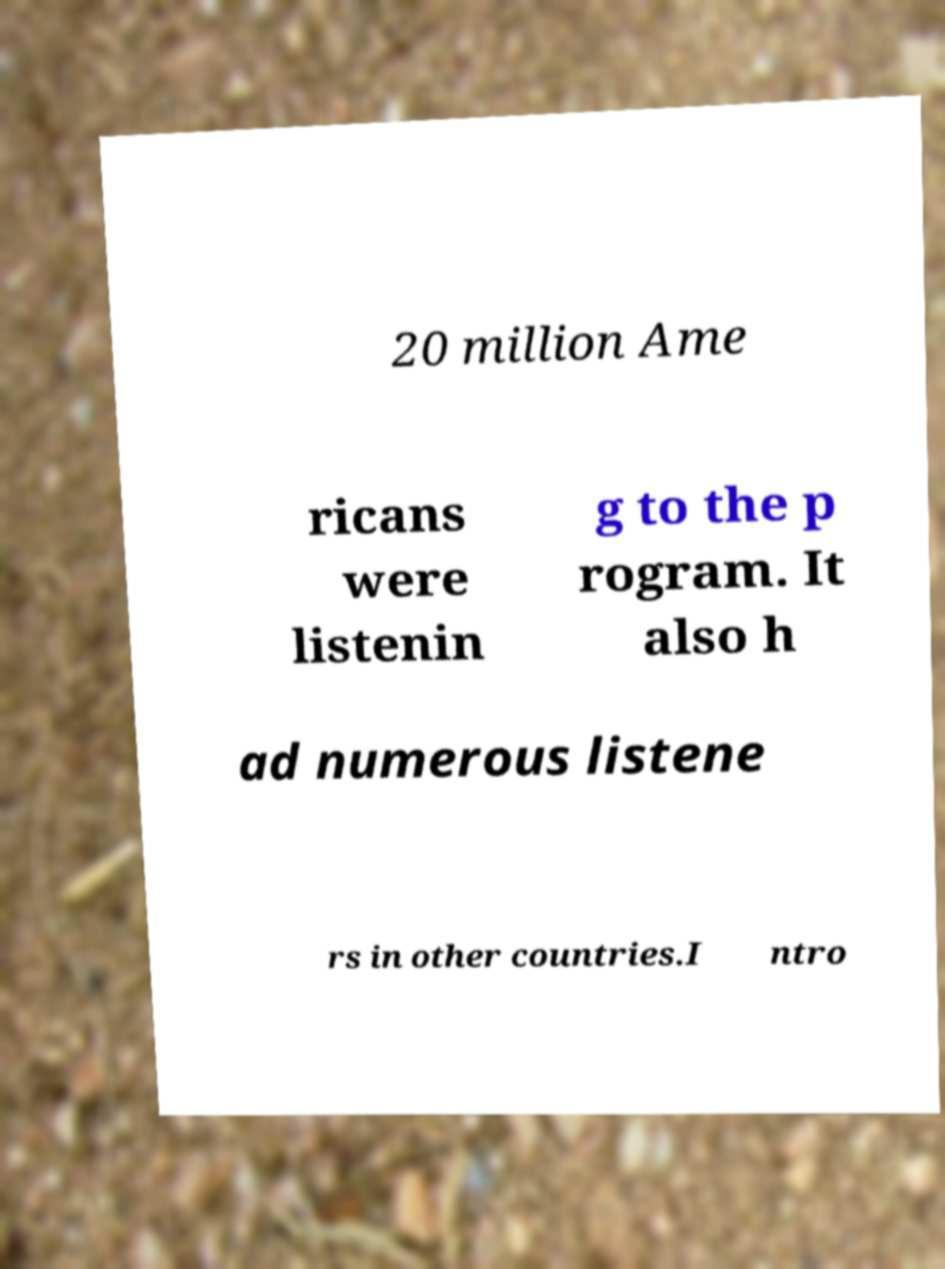What messages or text are displayed in this image? I need them in a readable, typed format. 20 million Ame ricans were listenin g to the p rogram. It also h ad numerous listene rs in other countries.I ntro 